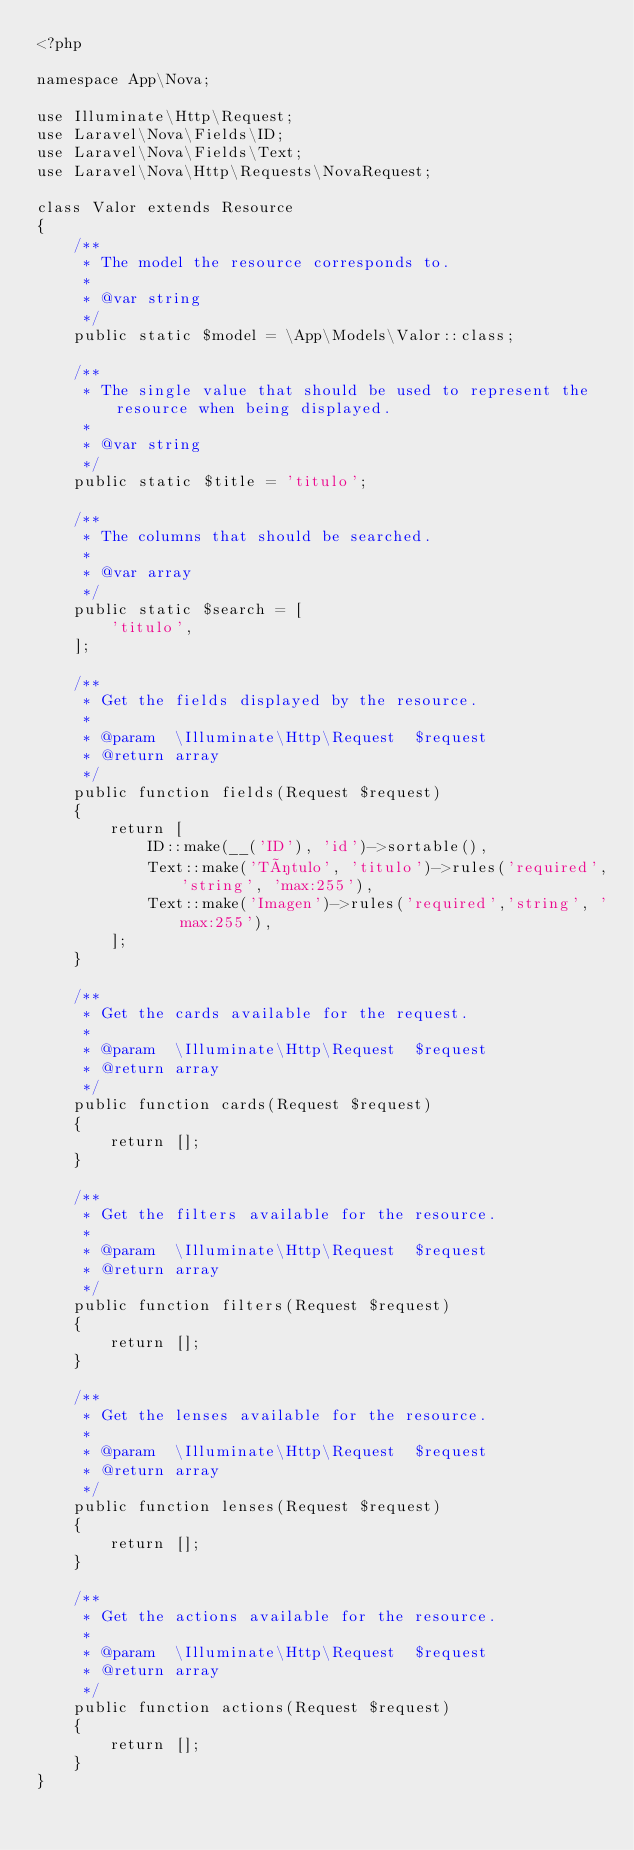<code> <loc_0><loc_0><loc_500><loc_500><_PHP_><?php

namespace App\Nova;

use Illuminate\Http\Request;
use Laravel\Nova\Fields\ID;
use Laravel\Nova\Fields\Text;
use Laravel\Nova\Http\Requests\NovaRequest;

class Valor extends Resource
{
    /**
     * The model the resource corresponds to.
     *
     * @var string
     */
    public static $model = \App\Models\Valor::class;

    /**
     * The single value that should be used to represent the resource when being displayed.
     *
     * @var string
     */
    public static $title = 'titulo';

    /**
     * The columns that should be searched.
     *
     * @var array
     */
    public static $search = [
        'titulo',
    ];

    /**
     * Get the fields displayed by the resource.
     *
     * @param  \Illuminate\Http\Request  $request
     * @return array
     */
    public function fields(Request $request)
    {
        return [
            ID::make(__('ID'), 'id')->sortable(),
            Text::make('Título', 'titulo')->rules('required','string', 'max:255'),
            Text::make('Imagen')->rules('required','string', 'max:255'),
        ];
    }

    /**
     * Get the cards available for the request.
     *
     * @param  \Illuminate\Http\Request  $request
     * @return array
     */
    public function cards(Request $request)
    {
        return [];
    }

    /**
     * Get the filters available for the resource.
     *
     * @param  \Illuminate\Http\Request  $request
     * @return array
     */
    public function filters(Request $request)
    {
        return [];
    }

    /**
     * Get the lenses available for the resource.
     *
     * @param  \Illuminate\Http\Request  $request
     * @return array
     */
    public function lenses(Request $request)
    {
        return [];
    }

    /**
     * Get the actions available for the resource.
     *
     * @param  \Illuminate\Http\Request  $request
     * @return array
     */
    public function actions(Request $request)
    {
        return [];
    }
}
</code> 